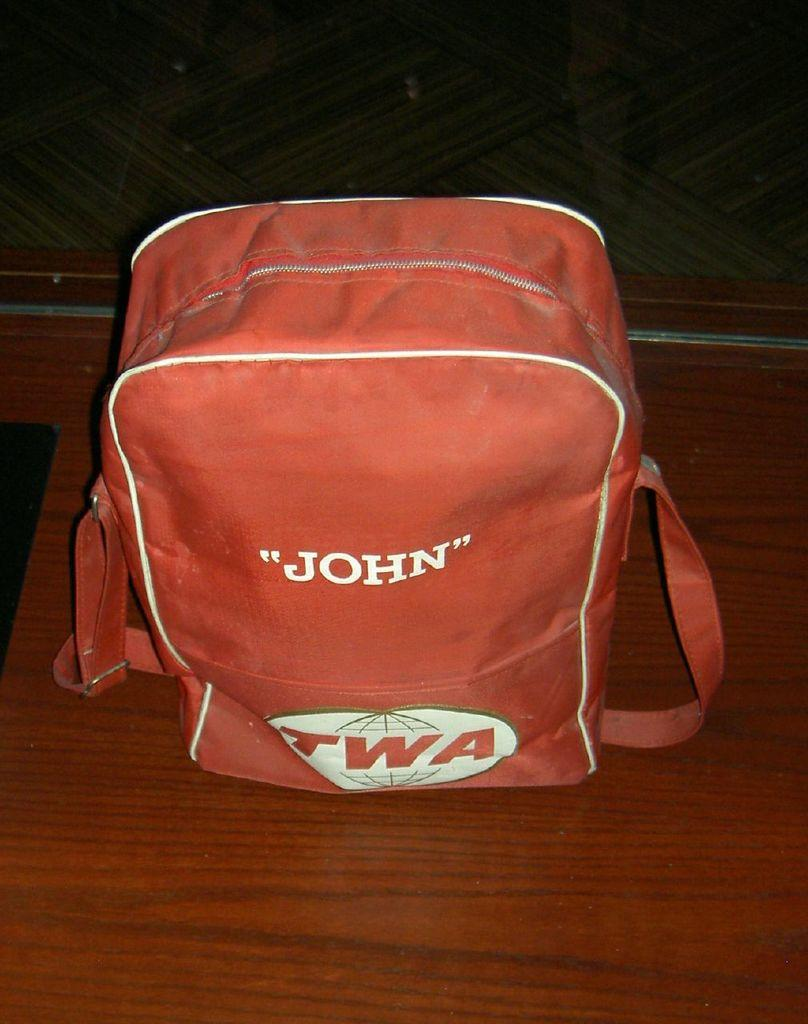What object is present in the image? There is a bag in the image. Where is the bag located? The bag is on a platform. What can be seen in the background of the image? There is a wall in the background of the image. How many bikes are parked next to the bag in the image? There are no bikes present in the image. What type of insect can be seen crawling on the bag in the image? There are no insects present on the bag in the image. 